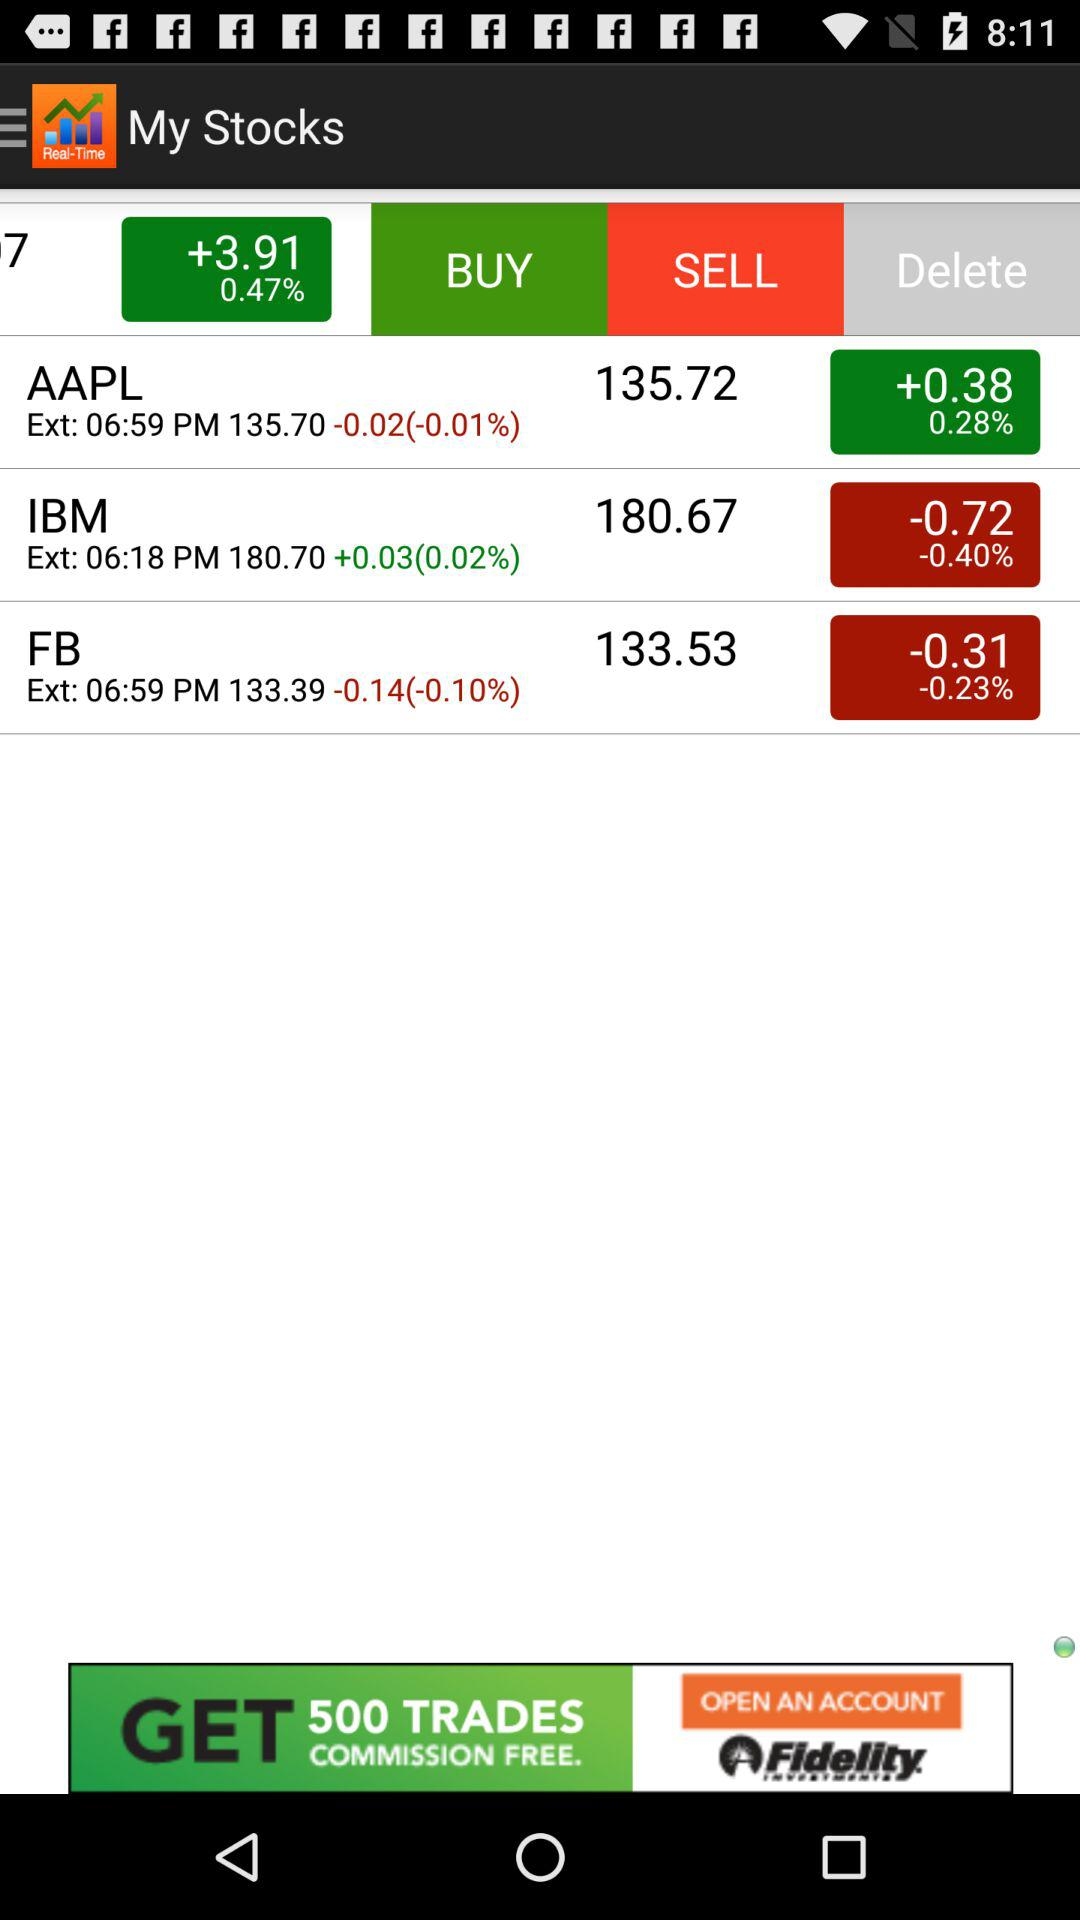Which stock has a price of 133.53? The stock that has a price of 133.53 is FB. 